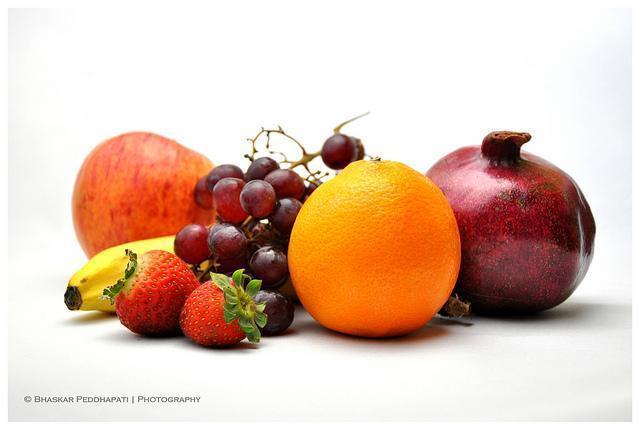How many different foods are there?
Give a very brief answer. 6. How many dogs are wearing a leash?
Give a very brief answer. 0. 